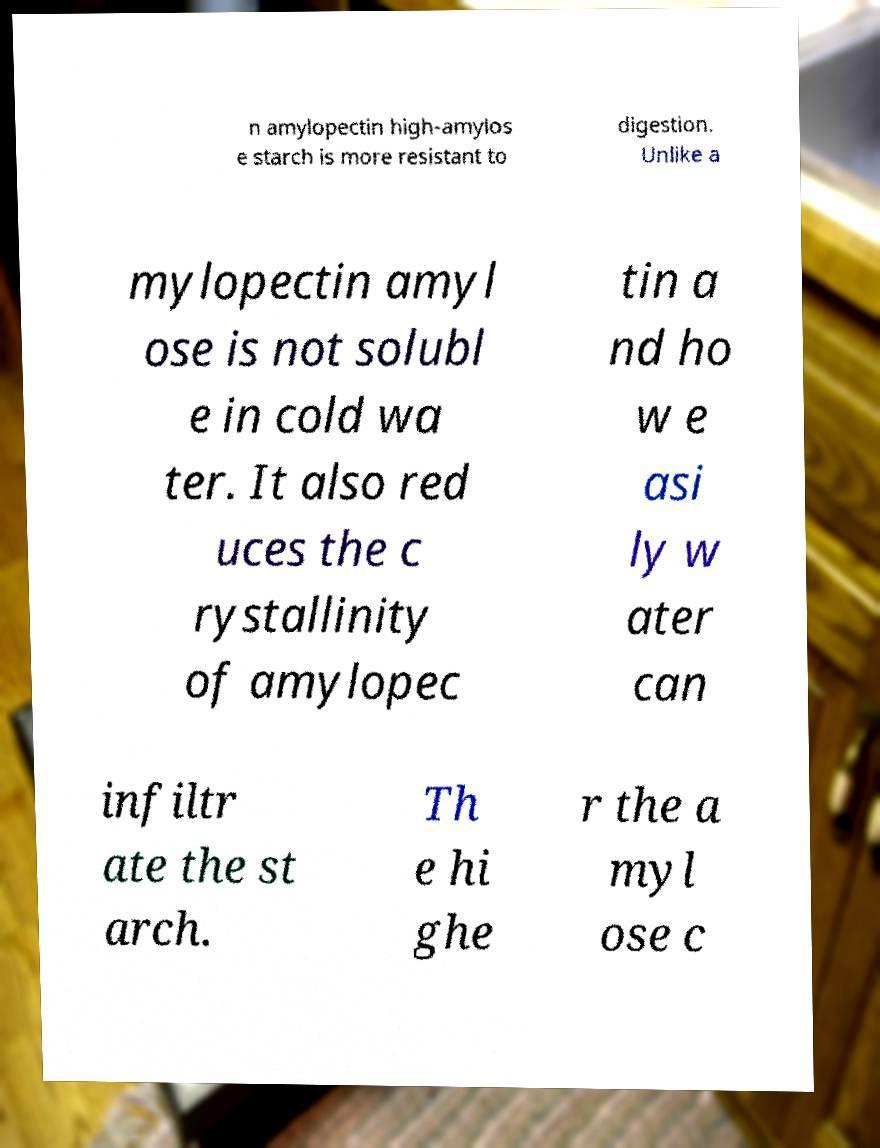Can you accurately transcribe the text from the provided image for me? n amylopectin high-amylos e starch is more resistant to digestion. Unlike a mylopectin amyl ose is not solubl e in cold wa ter. It also red uces the c rystallinity of amylopec tin a nd ho w e asi ly w ater can infiltr ate the st arch. Th e hi ghe r the a myl ose c 